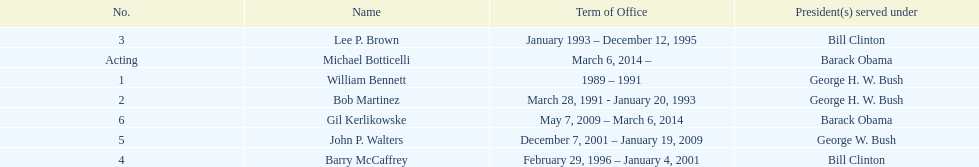How long did bob martinez serve as director? 2 years. 